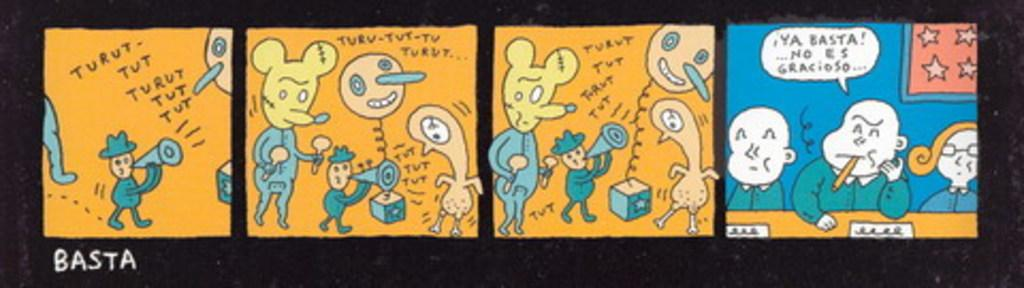Provide a one-sentence caption for the provided image. The Sunday cartoon strip is in Spanish and is very comical. 